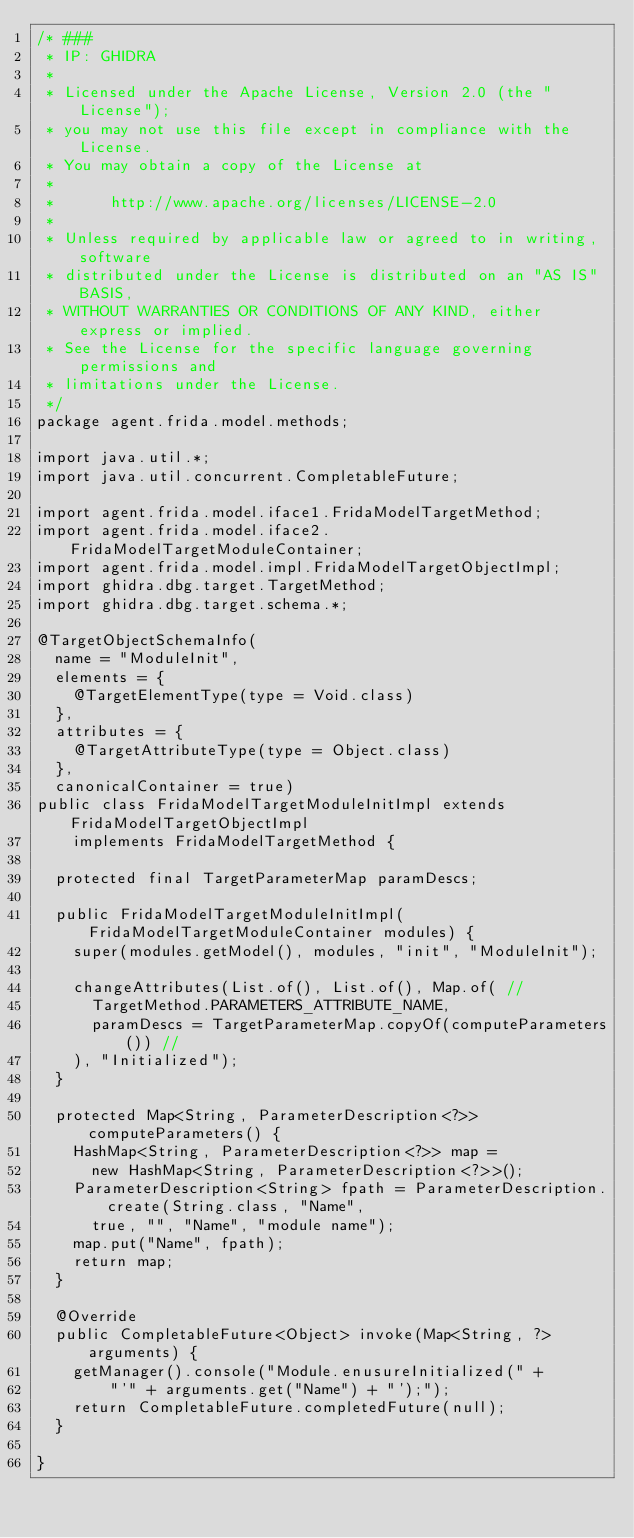Convert code to text. <code><loc_0><loc_0><loc_500><loc_500><_Java_>/* ###
 * IP: GHIDRA
 *
 * Licensed under the Apache License, Version 2.0 (the "License");
 * you may not use this file except in compliance with the License.
 * You may obtain a copy of the License at
 * 
 *      http://www.apache.org/licenses/LICENSE-2.0
 * 
 * Unless required by applicable law or agreed to in writing, software
 * distributed under the License is distributed on an "AS IS" BASIS,
 * WITHOUT WARRANTIES OR CONDITIONS OF ANY KIND, either express or implied.
 * See the License for the specific language governing permissions and
 * limitations under the License.
 */
package agent.frida.model.methods;

import java.util.*;
import java.util.concurrent.CompletableFuture;

import agent.frida.model.iface1.FridaModelTargetMethod;
import agent.frida.model.iface2.FridaModelTargetModuleContainer;
import agent.frida.model.impl.FridaModelTargetObjectImpl;
import ghidra.dbg.target.TargetMethod;
import ghidra.dbg.target.schema.*;

@TargetObjectSchemaInfo(
	name = "ModuleInit",
	elements = {
		@TargetElementType(type = Void.class)
	},
	attributes = {
		@TargetAttributeType(type = Object.class)
	},
	canonicalContainer = true)
public class FridaModelTargetModuleInitImpl extends FridaModelTargetObjectImpl
		implements FridaModelTargetMethod {

	protected final TargetParameterMap paramDescs;

	public FridaModelTargetModuleInitImpl(FridaModelTargetModuleContainer modules) {
		super(modules.getModel(), modules, "init", "ModuleInit");
		
		changeAttributes(List.of(), List.of(), Map.of( //
			TargetMethod.PARAMETERS_ATTRIBUTE_NAME,
			paramDescs = TargetParameterMap.copyOf(computeParameters()) //
		), "Initialized");
	}

	protected Map<String, ParameterDescription<?>> computeParameters() {
		HashMap<String, ParameterDescription<?>> map =
			new HashMap<String, ParameterDescription<?>>();
		ParameterDescription<String> fpath = ParameterDescription.create(String.class, "Name",
			true, "", "Name", "module name");
		map.put("Name", fpath);
		return map;
	}
	
	@Override
	public CompletableFuture<Object> invoke(Map<String, ?> arguments) {
		getManager().console("Module.enusureInitialized(" + 
				"'" + arguments.get("Name") + "');");
		return CompletableFuture.completedFuture(null);
	}

}
</code> 